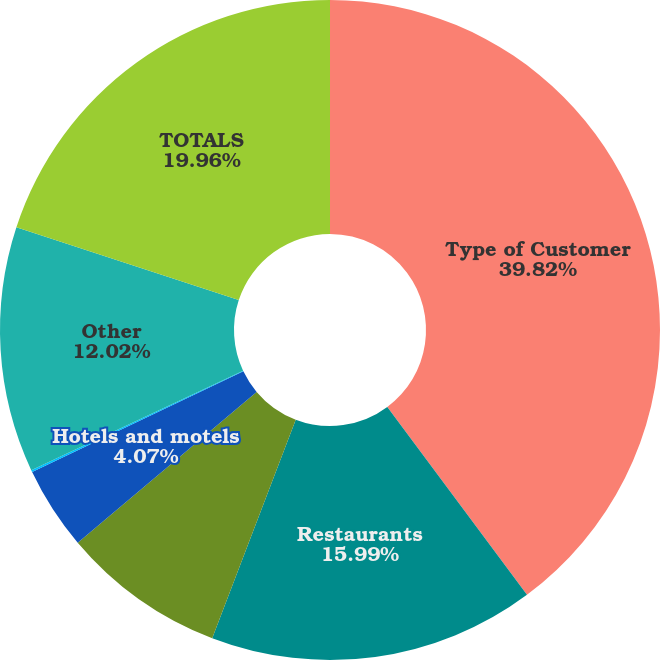Convert chart to OTSL. <chart><loc_0><loc_0><loc_500><loc_500><pie_chart><fcel>Type of Customer<fcel>Restaurants<fcel>Hospitals and nursing homes<fcel>Hotels and motels<fcel>Schools and colleges<fcel>Other<fcel>TOTALS<nl><fcel>39.82%<fcel>15.99%<fcel>8.04%<fcel>4.07%<fcel>0.1%<fcel>12.02%<fcel>19.96%<nl></chart> 